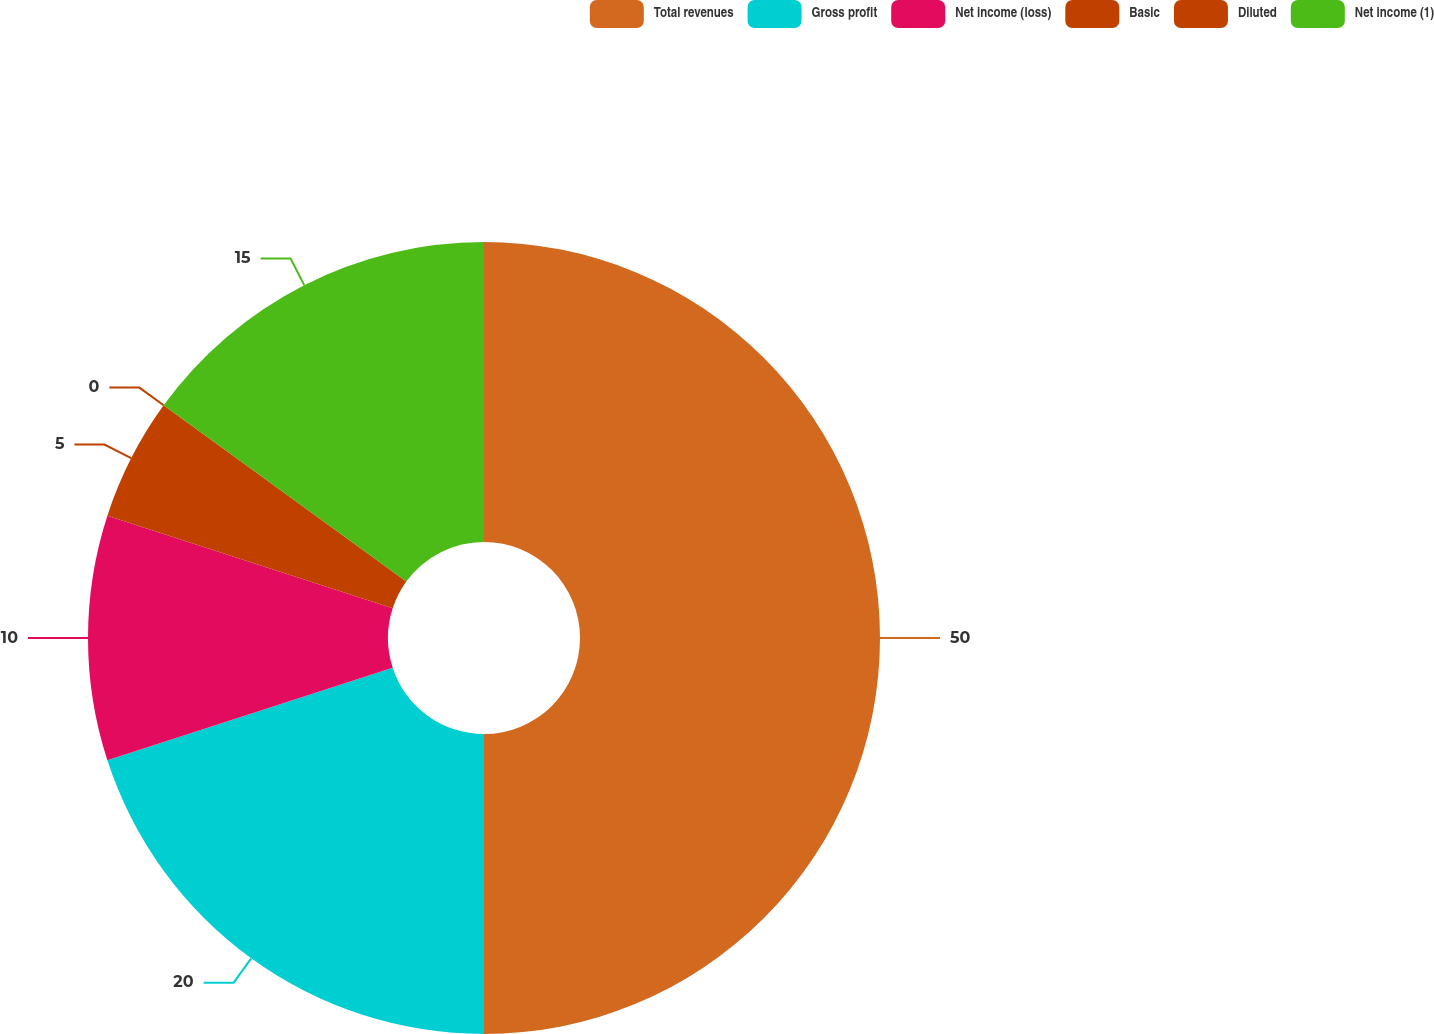Convert chart to OTSL. <chart><loc_0><loc_0><loc_500><loc_500><pie_chart><fcel>Total revenues<fcel>Gross profit<fcel>Net income (loss)<fcel>Basic<fcel>Diluted<fcel>Net income (1)<nl><fcel>50.0%<fcel>20.0%<fcel>10.0%<fcel>5.0%<fcel>0.0%<fcel>15.0%<nl></chart> 